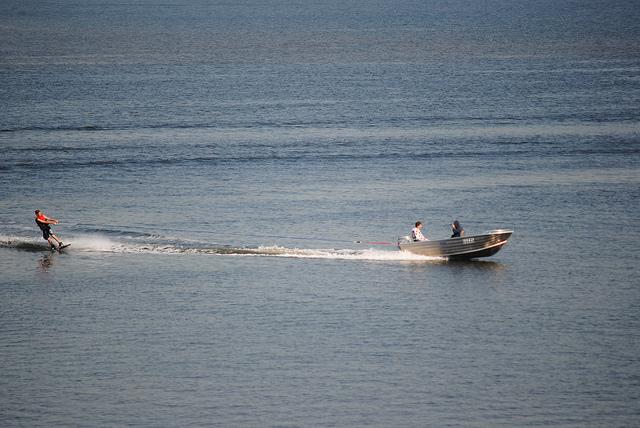Is the boat going straight or turning?
Give a very brief answer. Straight. Are the waves calm?
Concise answer only. Yes. What is the person to the far left holding onto?
Concise answer only. Rope. How many people are shown?
Keep it brief. 3. Is this boat going to the right?
Quick response, please. Yes. 